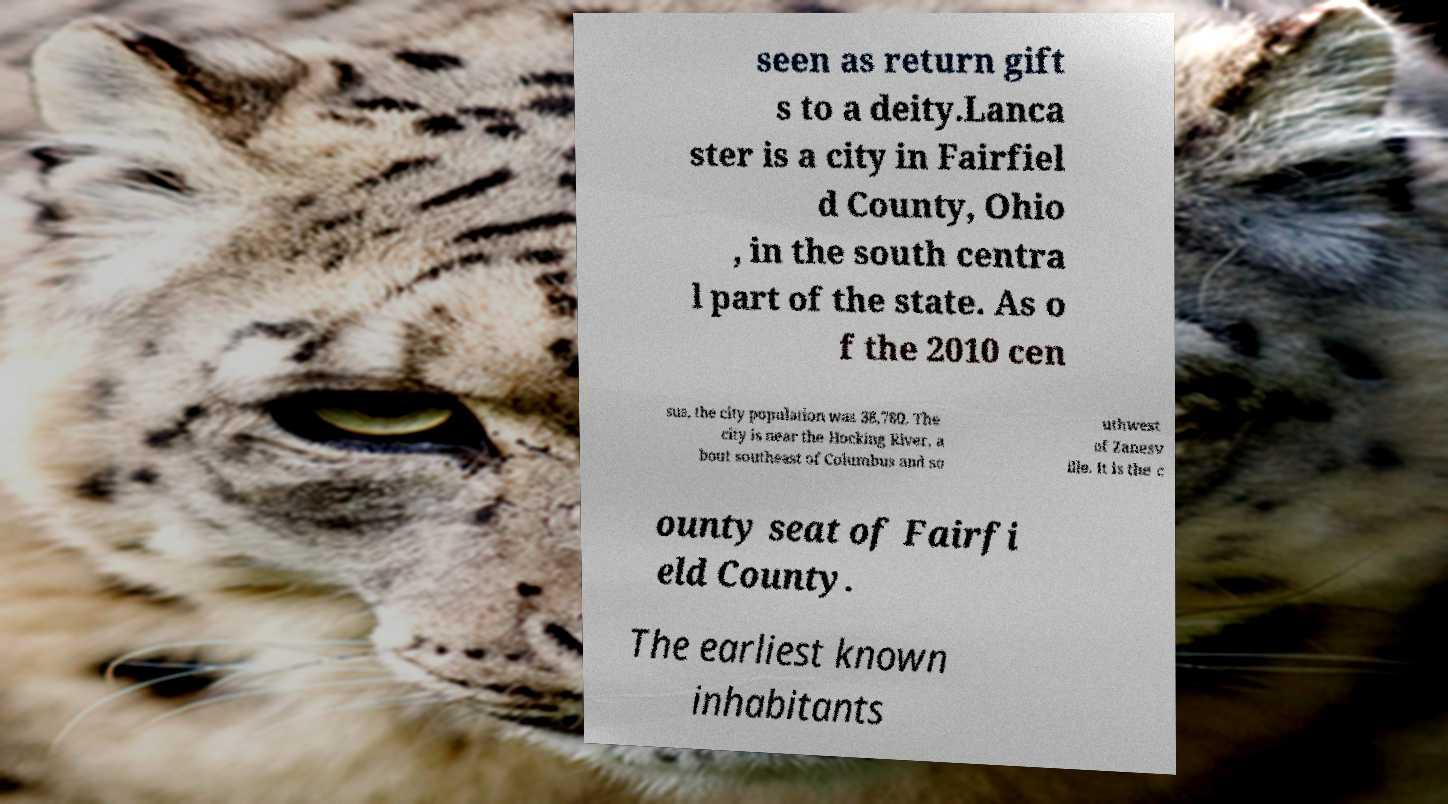I need the written content from this picture converted into text. Can you do that? seen as return gift s to a deity.Lanca ster is a city in Fairfiel d County, Ohio , in the south centra l part of the state. As o f the 2010 cen sus, the city population was 38,780. The city is near the Hocking River, a bout southeast of Columbus and so uthwest of Zanesv ille. It is the c ounty seat of Fairfi eld County. The earliest known inhabitants 